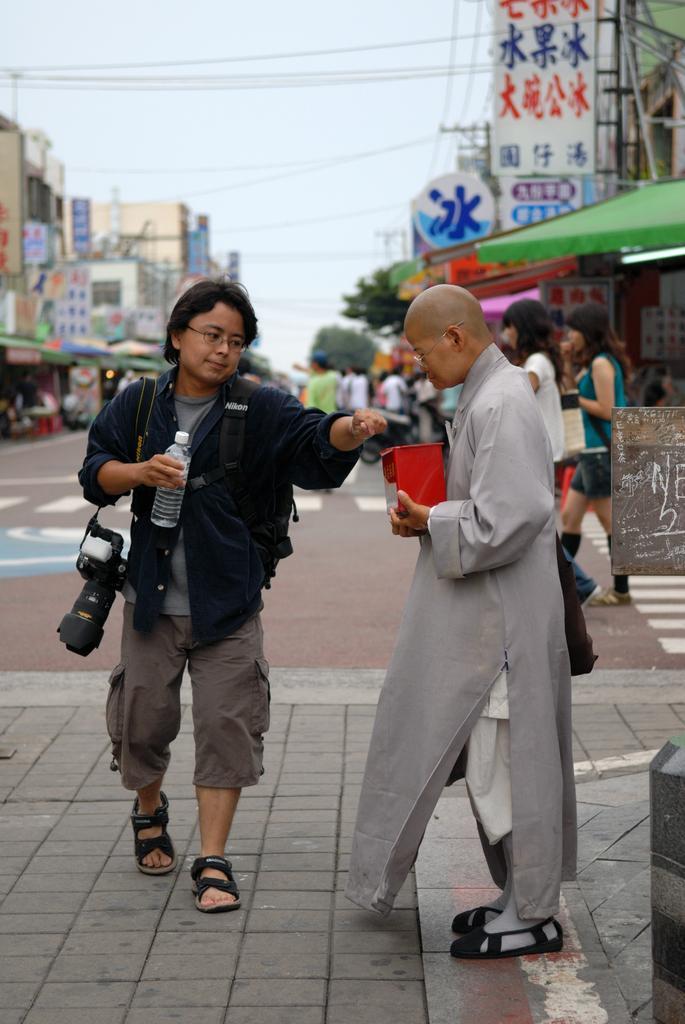Can you describe this image briefly? A person is holding bottle and carrying camera. A person is holding box, here there are other people standing on the road, there are buildings and a sky. 